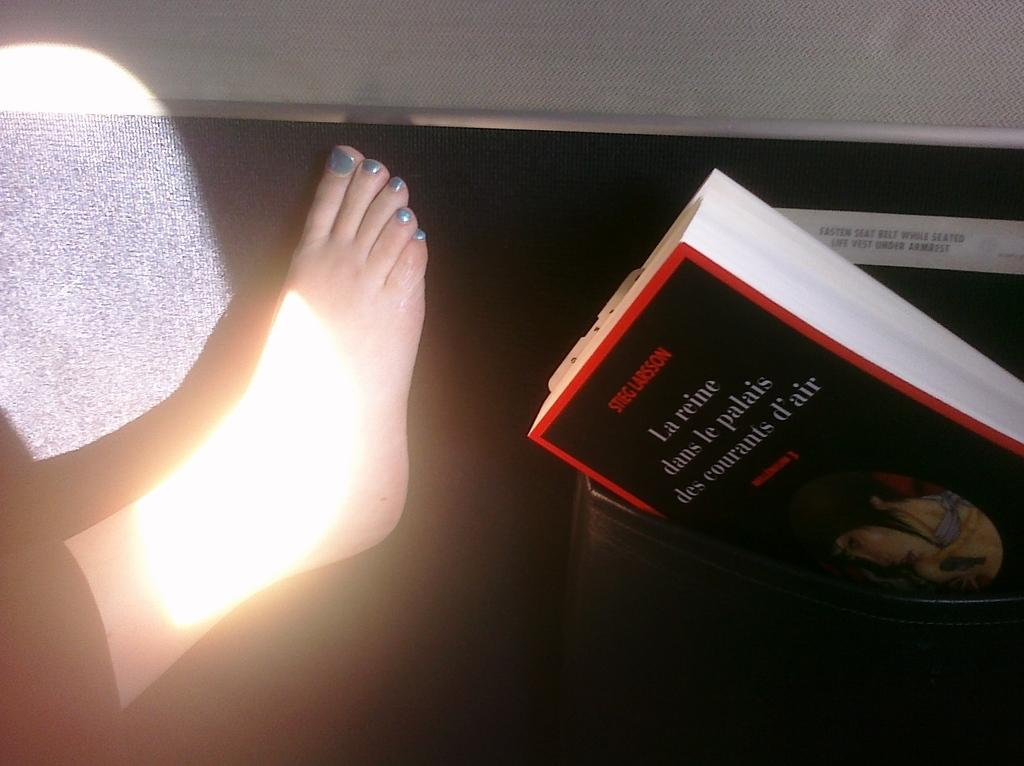<image>
Share a concise interpretation of the image provided. A Stieg Larsson book in a box next to a foot that has painted toe nails. 